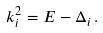<formula> <loc_0><loc_0><loc_500><loc_500>k _ { i } ^ { 2 } = E - \Delta _ { i } \, .</formula> 